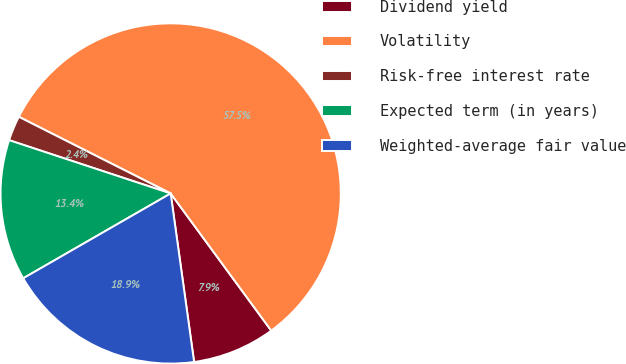<chart> <loc_0><loc_0><loc_500><loc_500><pie_chart><fcel>Dividend yield<fcel>Volatility<fcel>Risk-free interest rate<fcel>Expected term (in years)<fcel>Weighted-average fair value<nl><fcel>7.87%<fcel>57.49%<fcel>2.37%<fcel>13.38%<fcel>18.89%<nl></chart> 